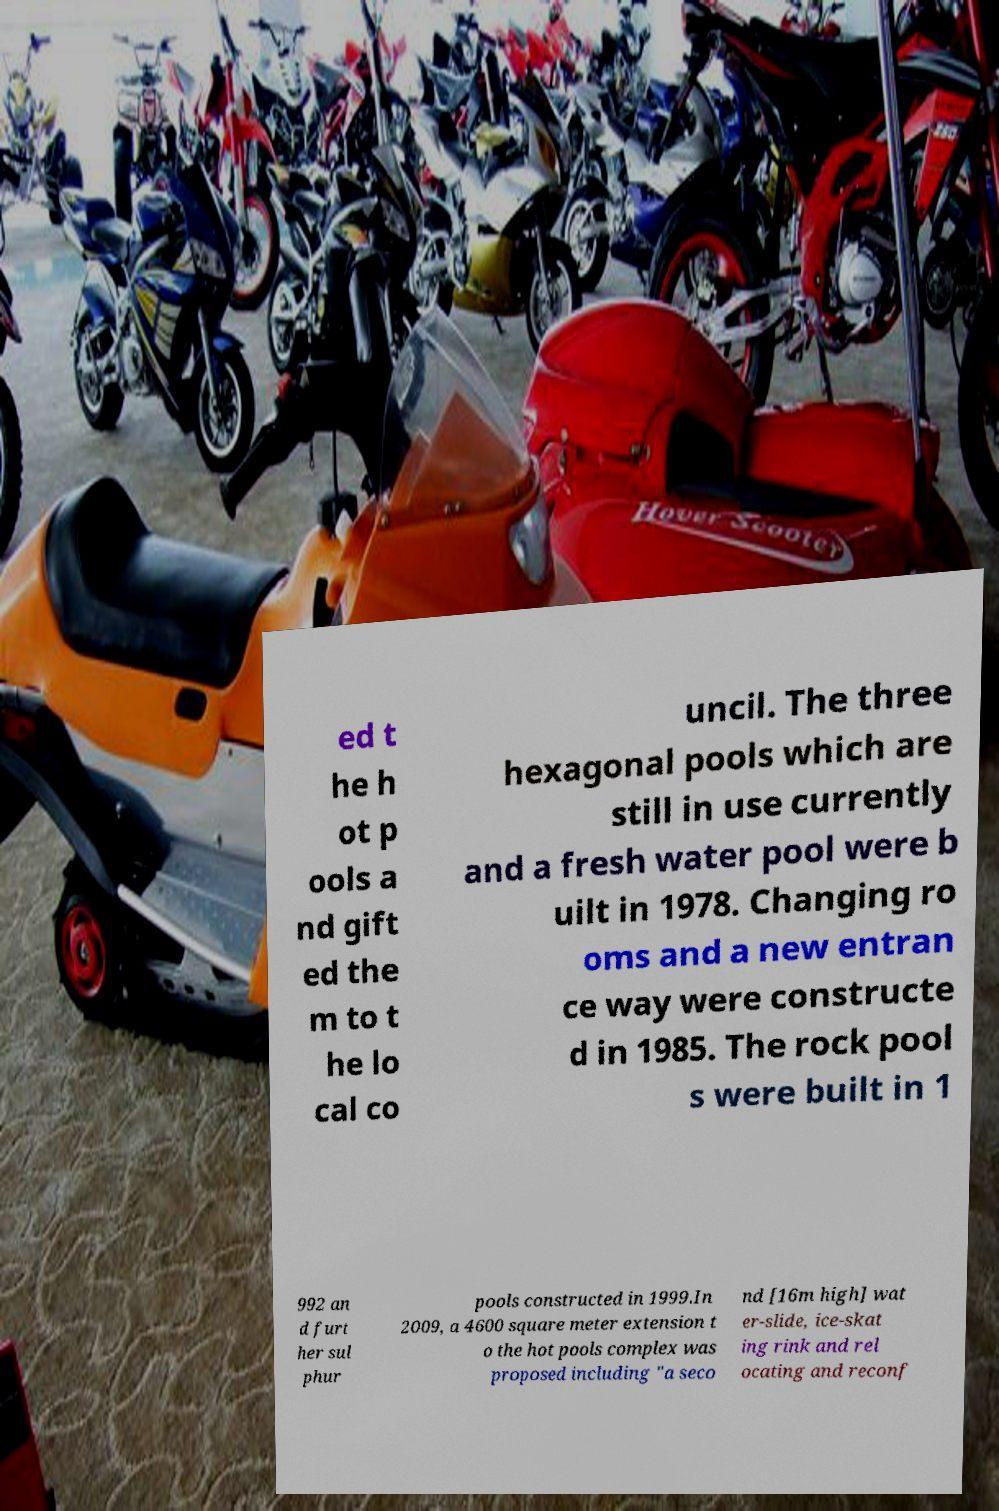Can you accurately transcribe the text from the provided image for me? ed t he h ot p ools a nd gift ed the m to t he lo cal co uncil. The three hexagonal pools which are still in use currently and a fresh water pool were b uilt in 1978. Changing ro oms and a new entran ce way were constructe d in 1985. The rock pool s were built in 1 992 an d furt her sul phur pools constructed in 1999.In 2009, a 4600 square meter extension t o the hot pools complex was proposed including "a seco nd [16m high] wat er-slide, ice-skat ing rink and rel ocating and reconf 